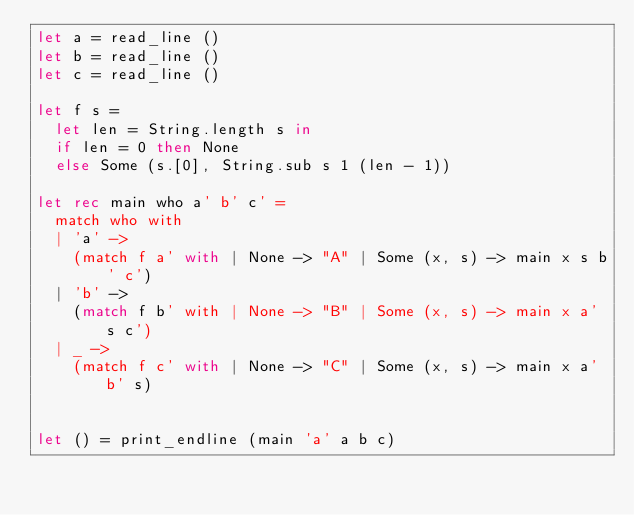Convert code to text. <code><loc_0><loc_0><loc_500><loc_500><_OCaml_>let a = read_line ()
let b = read_line ()
let c = read_line ()

let f s =
  let len = String.length s in
  if len = 0 then None
  else Some (s.[0], String.sub s 1 (len - 1))

let rec main who a' b' c' =
  match who with
  | 'a' ->
    (match f a' with | None -> "A" | Some (x, s) -> main x s b' c')
  | 'b' -> 
    (match f b' with | None -> "B" | Some (x, s) -> main x a' s c')
  | _ ->  
    (match f c' with | None -> "C" | Some (x, s) -> main x a' b' s)


let () = print_endline (main 'a' a b c)</code> 